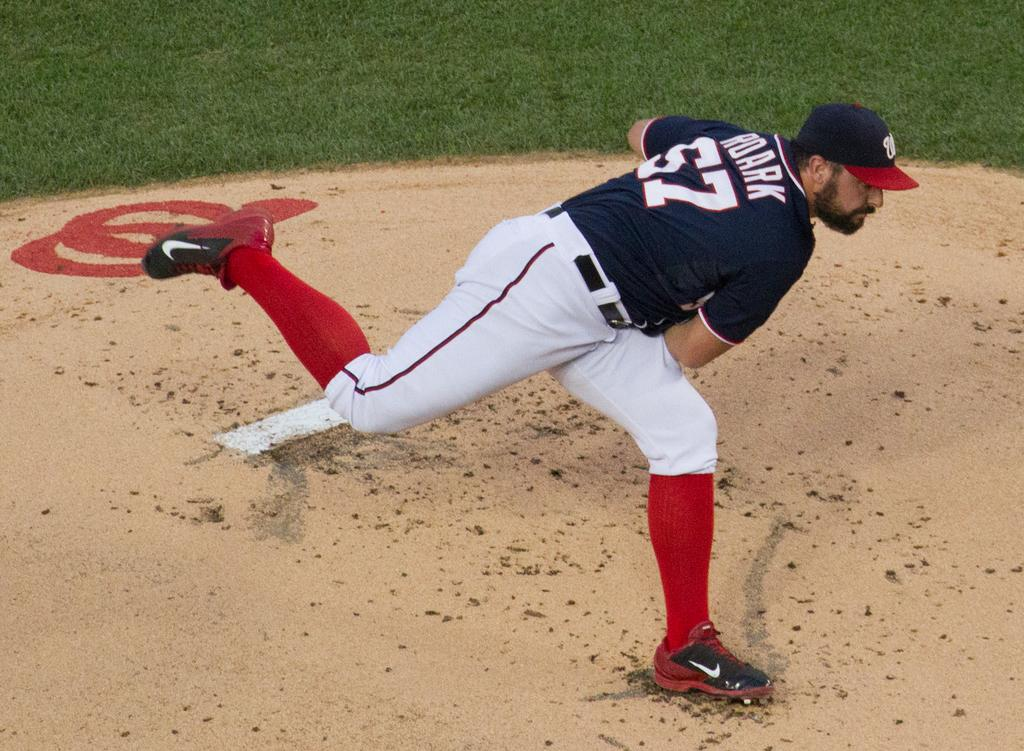Where was the image taken? The image was taken in a playground. Can you describe the person wearing a cap in the image? There is a player with a cap in the image. What type of vegetation can be seen in the background of the image? There is grass in the background of the image. What type of terrain is visible in the background of the image? There is sand in the background of the image. What type of lettuce can be seen in the image? There is no lettuce present in the image. 